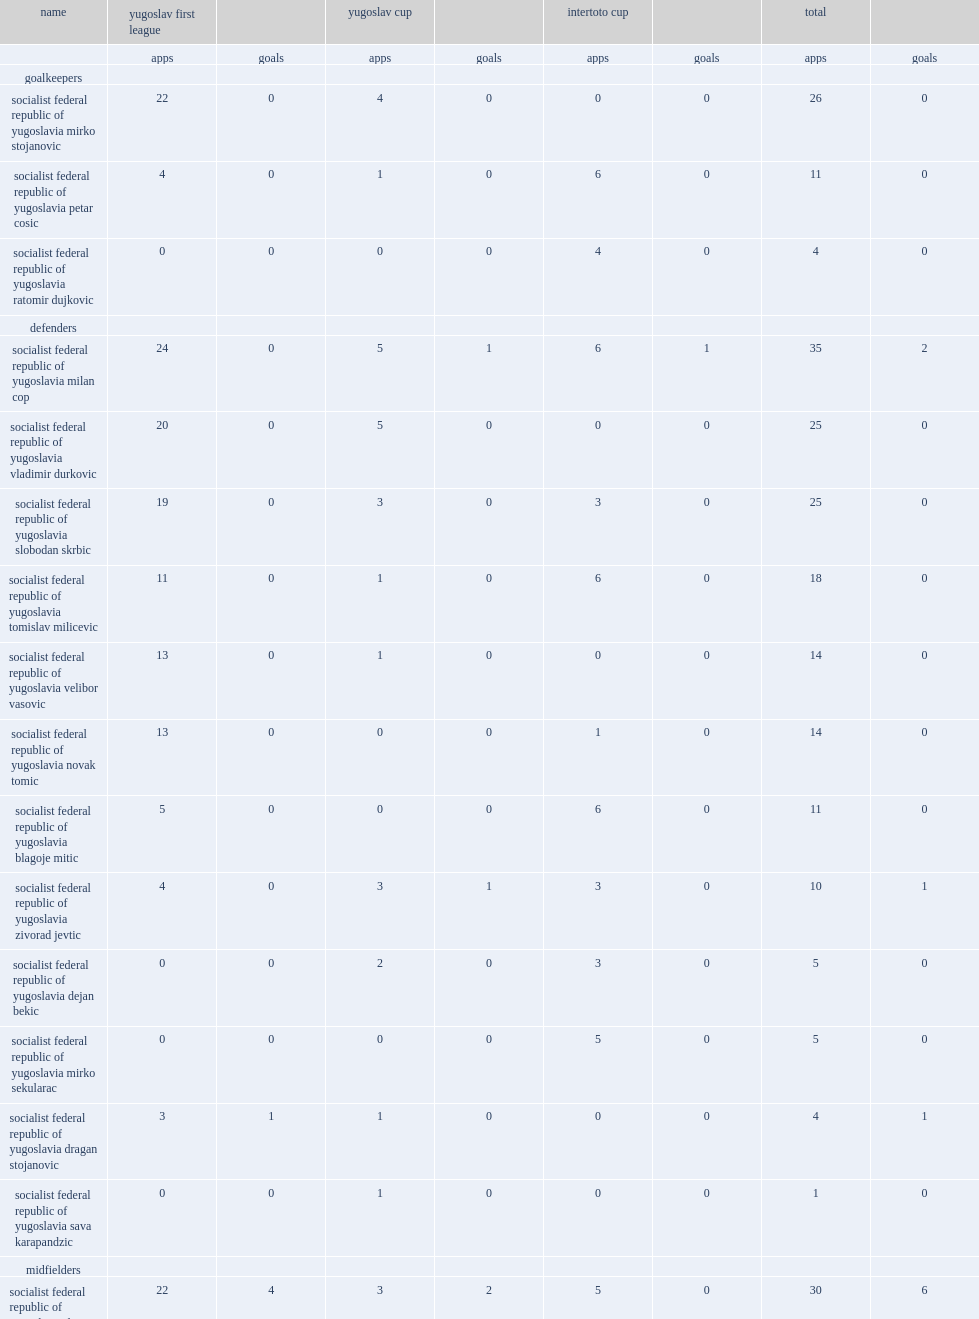What the matches did red star belgrade participate in? Yugoslav first league yugoslav cup intertoto cup. 